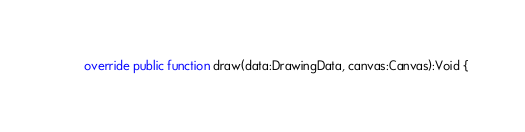<code> <loc_0><loc_0><loc_500><loc_500><_Haxe_>	override public function draw(data:DrawingData, canvas:Canvas):Void {</code> 